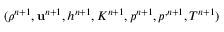Convert formula to latex. <formula><loc_0><loc_0><loc_500><loc_500>( \rho ^ { n + 1 } , \mathbf u ^ { n + 1 } , h ^ { n + 1 } , K ^ { n + 1 } , p ^ { n + 1 } , p ^ { , n + 1 } , T ^ { n + 1 } )</formula> 